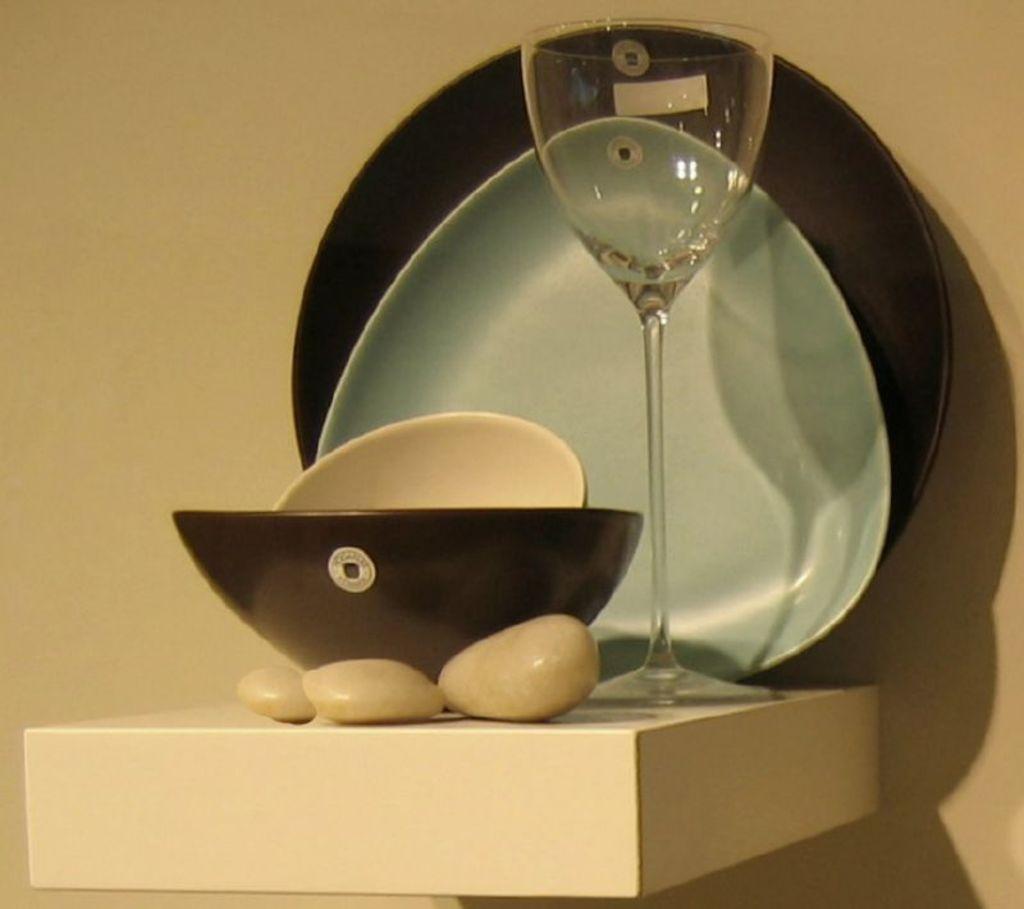Please provide a concise description of this image. In this image we can see bowel, stones, plates and glass on table. In the background of the image there is wall. 